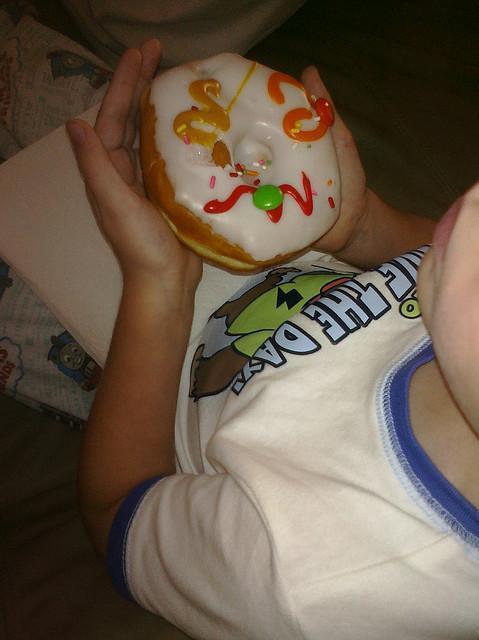How many donuts can be seen?
Give a very brief answer. 1. 